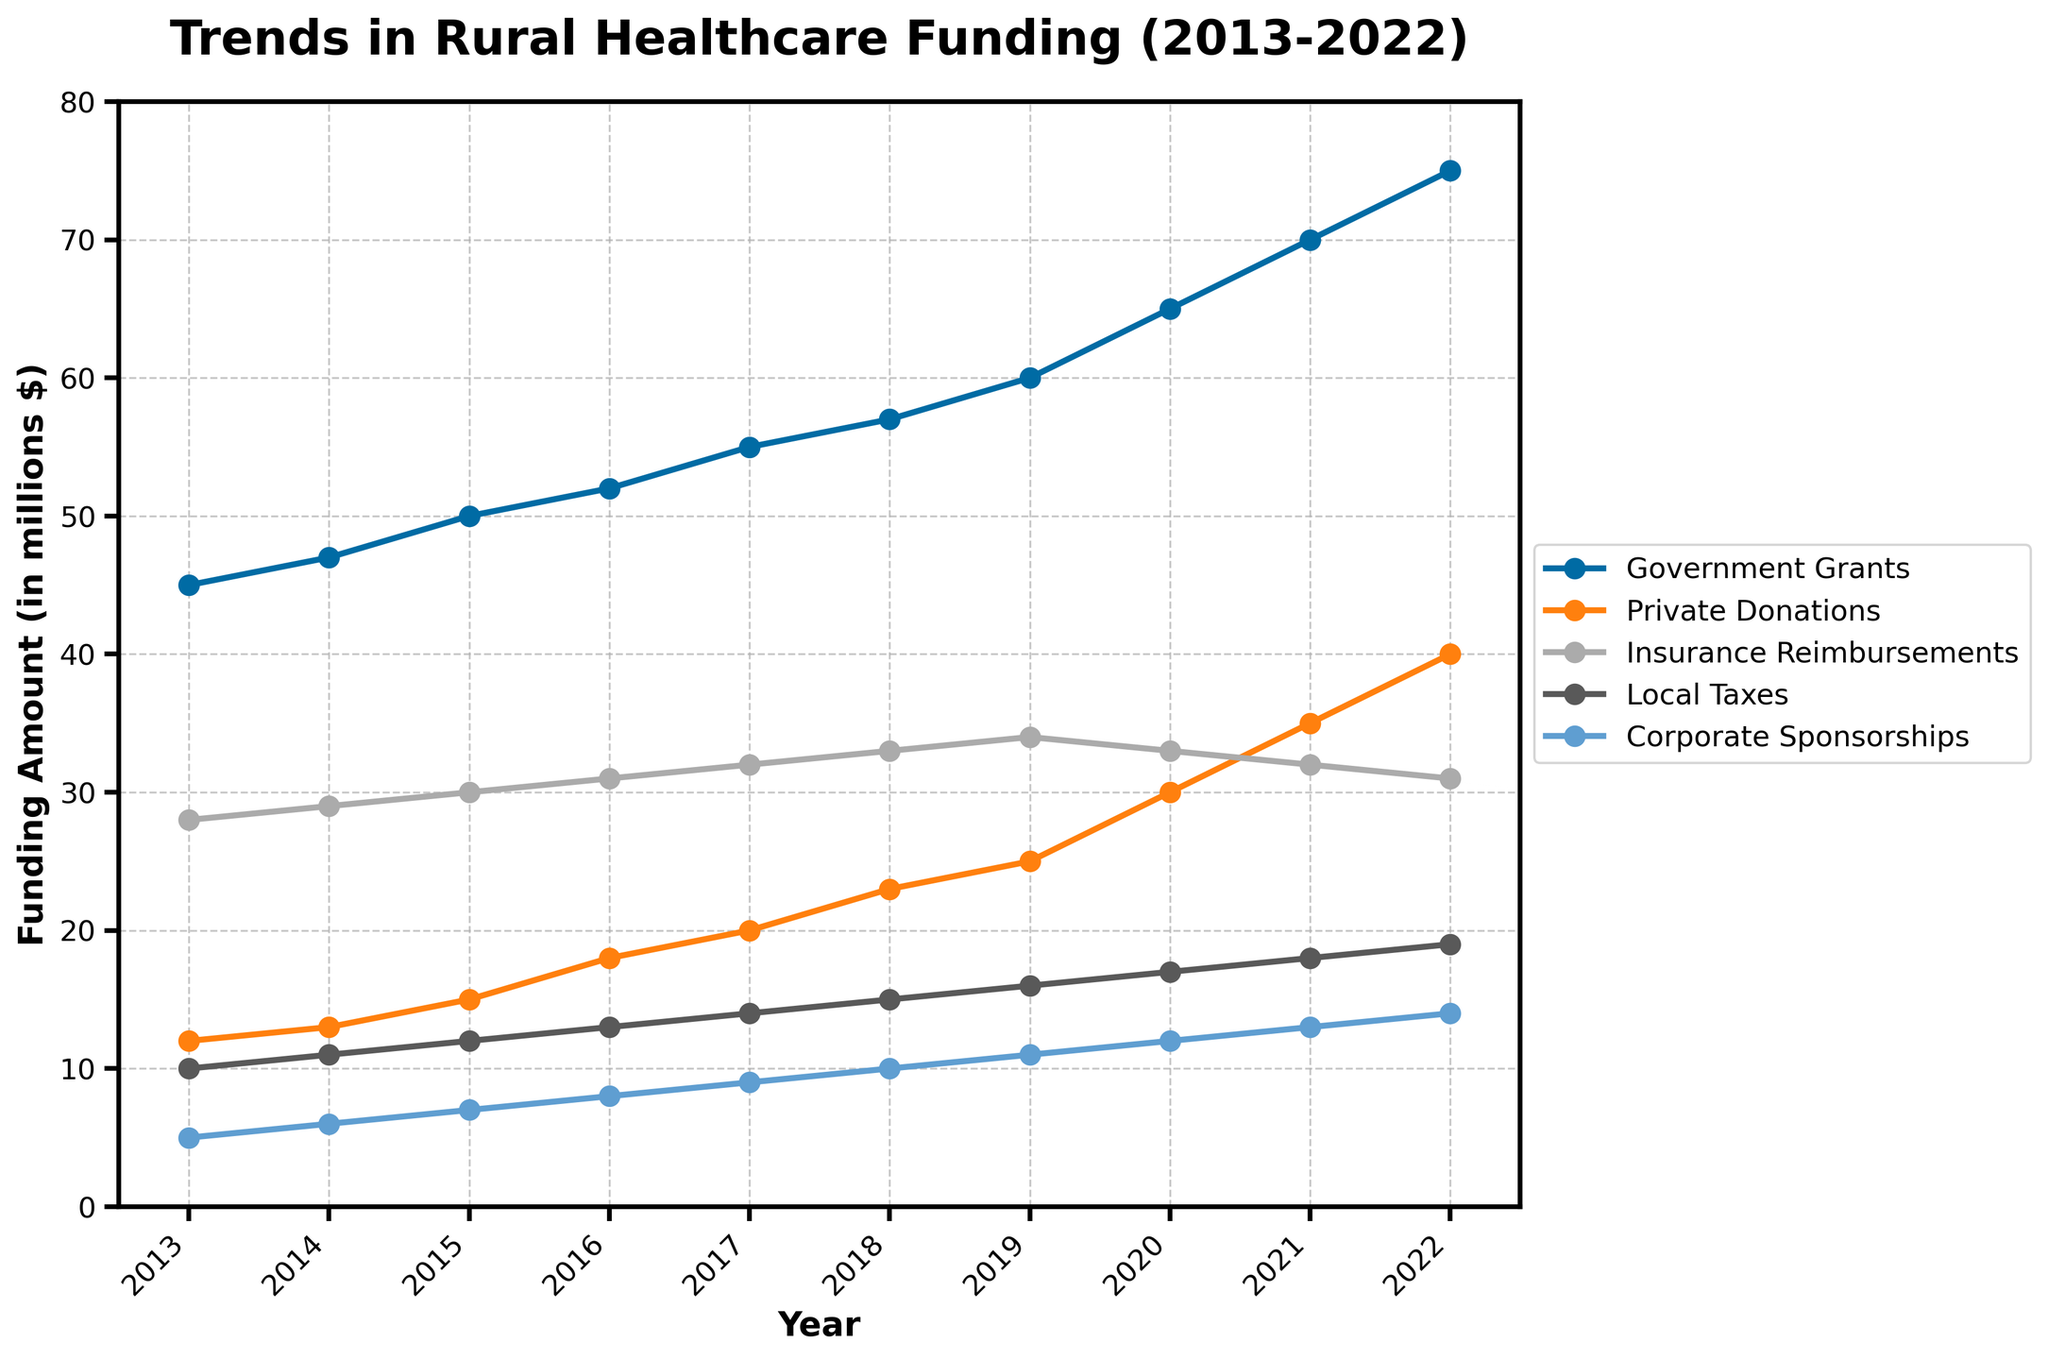What is the total government funding across the entire decade? Add up the values of Government Grants from 2013 to 2022. 45 + 47 + 50 + 52 + 55 + 57 + 60 + 65 + 70 + 75 = 576
Answer: 576 Between which years did Private Donations see the highest increase? Compare the year-over-year differences for Private Donations. 13-12 (2013-2014) = 1, 15-13 (2014-2015) = 2, 18-15 (2015-2016) = 3, 20-18 (2016-2017) = 2, 23-20 (2017-2018) = 3, 25-23 (2018-2019) = 2, 30-25 (2019-2020) = 5, 35-30 (2020-2021) = 5, 40-35 (2021-2022) = 5. The highest increases (5) occurred between 2019-2020, 2020-2021, and 2021-2022
Answer: 2019-2020, 2020-2021, 2021-2022 Which funding source had the highest amount in 2020? Check the values of all funding sources for 2020. Government Grants = 65, Private Donations = 30, Insurance Reimbursements = 33, Local Taxes = 17, Corporate Sponsorships = 12. The highest amount is 65 (Government Grants)
Answer: Government Grants What was the average annual amount of Corporate Sponsorships over the decade? Calculate the average by summing Corporate Sponsorships from 2013 to 2022 and divide by 10. (5 + 6 + 7 + 8 + 9 + 10 + 11 + 12 + 13 + 14) / 10 = 95 / 10
Answer: 9.5 In which year did Local Taxes reach 15 million? Refer to the values of Local Taxes and find the corresponding year. The value reaches 15 million in 2018
Answer: 2018 Which funding source saw a decline in 2020 compared to 2019? Compare the values from 2019 and 2020 for each funding source. Government Grants: 60->65 (increase), Private Donations: 25->30 (increase), Insurance Reimbursements: 34->33 (decline), Local Taxes: 16->17 (increase), Corporate Sponsorships: 11->12 (increase). Insurance Reimbursements saw a decline
Answer: Insurance Reimbursements What is the combined amount of non-governmental funding sources in 2022? Sum the values of Private Donations, Insurance Reimbursements, Local Taxes, Corporate Sponsorships for 2022. 40 + 31 + 19 + 14 = 104
Answer: 104 By how many millions did Government Grants grow from 2013 to 2022? Subtract the value of Government Grants in 2013 from that in 2022. 75 - 45 = 30
Answer: 30 Which funding source had the least variation in amounts over the decade? Analyze the range (max - min) for each funding source. Government Grants: 75-45 = 30, Private Donations: 40-12 = 28, Insurance Reimbursements: 34-28 = 6, Local Taxes: 19-10 = 9, Corporate Sponsorships: 14-5 = 9. Insurance Reimbursements had the least variation
Answer: Insurance Reimbursements 